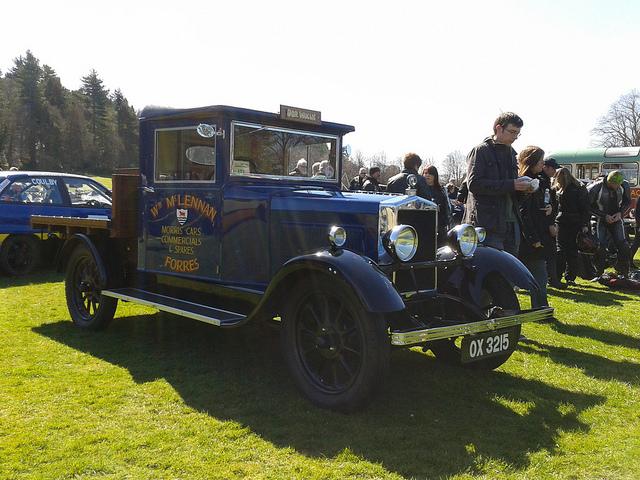Is it grassy?
Be succinct. Yes. Is this an old model car?
Keep it brief. Yes. What is cast?
Short answer required. Car. 